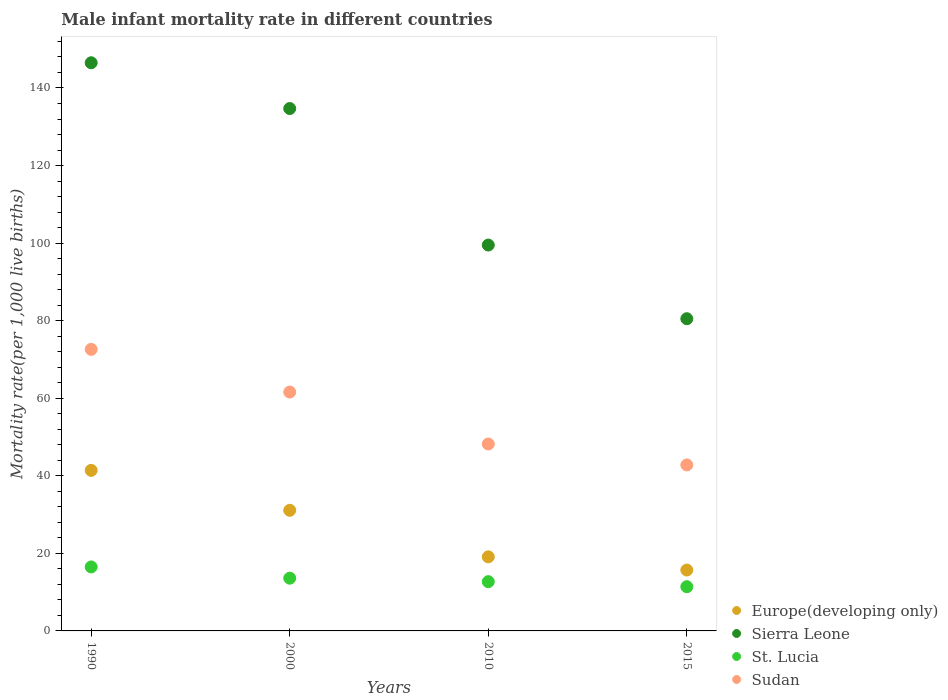What is the male infant mortality rate in Sierra Leone in 1990?
Keep it short and to the point. 146.5. Across all years, what is the minimum male infant mortality rate in Sudan?
Your response must be concise. 42.8. In which year was the male infant mortality rate in Sierra Leone minimum?
Ensure brevity in your answer.  2015. What is the total male infant mortality rate in Sierra Leone in the graph?
Your answer should be compact. 461.2. What is the difference between the male infant mortality rate in Sierra Leone in 1990 and that in 2000?
Your answer should be compact. 11.8. What is the difference between the male infant mortality rate in St. Lucia in 1990 and the male infant mortality rate in Sudan in 2000?
Offer a terse response. -45.1. What is the average male infant mortality rate in St. Lucia per year?
Make the answer very short. 13.55. In the year 1990, what is the difference between the male infant mortality rate in Sudan and male infant mortality rate in St. Lucia?
Provide a succinct answer. 56.1. In how many years, is the male infant mortality rate in St. Lucia greater than 4?
Your answer should be compact. 4. What is the ratio of the male infant mortality rate in Sudan in 1990 to that in 2010?
Make the answer very short. 1.51. Is the male infant mortality rate in St. Lucia in 1990 less than that in 2000?
Ensure brevity in your answer.  No. What is the difference between the highest and the second highest male infant mortality rate in Sudan?
Your answer should be very brief. 11. What is the difference between the highest and the lowest male infant mortality rate in Sudan?
Provide a succinct answer. 29.8. Is the sum of the male infant mortality rate in Sudan in 1990 and 2000 greater than the maximum male infant mortality rate in Sierra Leone across all years?
Make the answer very short. No. Is it the case that in every year, the sum of the male infant mortality rate in St. Lucia and male infant mortality rate in Sierra Leone  is greater than the male infant mortality rate in Sudan?
Your answer should be very brief. Yes. Is the male infant mortality rate in St. Lucia strictly greater than the male infant mortality rate in Sudan over the years?
Your answer should be very brief. No. Is the male infant mortality rate in Europe(developing only) strictly less than the male infant mortality rate in Sierra Leone over the years?
Your response must be concise. Yes. What is the difference between two consecutive major ticks on the Y-axis?
Offer a very short reply. 20. How many legend labels are there?
Provide a short and direct response. 4. What is the title of the graph?
Provide a succinct answer. Male infant mortality rate in different countries. What is the label or title of the Y-axis?
Give a very brief answer. Mortality rate(per 1,0 live births). What is the Mortality rate(per 1,000 live births) in Europe(developing only) in 1990?
Make the answer very short. 41.4. What is the Mortality rate(per 1,000 live births) in Sierra Leone in 1990?
Your answer should be compact. 146.5. What is the Mortality rate(per 1,000 live births) in St. Lucia in 1990?
Your response must be concise. 16.5. What is the Mortality rate(per 1,000 live births) in Sudan in 1990?
Ensure brevity in your answer.  72.6. What is the Mortality rate(per 1,000 live births) of Europe(developing only) in 2000?
Your answer should be very brief. 31.1. What is the Mortality rate(per 1,000 live births) of Sierra Leone in 2000?
Your answer should be compact. 134.7. What is the Mortality rate(per 1,000 live births) in Sudan in 2000?
Make the answer very short. 61.6. What is the Mortality rate(per 1,000 live births) of Sierra Leone in 2010?
Keep it short and to the point. 99.5. What is the Mortality rate(per 1,000 live births) of St. Lucia in 2010?
Provide a succinct answer. 12.7. What is the Mortality rate(per 1,000 live births) of Sudan in 2010?
Ensure brevity in your answer.  48.2. What is the Mortality rate(per 1,000 live births) of Sierra Leone in 2015?
Ensure brevity in your answer.  80.5. What is the Mortality rate(per 1,000 live births) of Sudan in 2015?
Your answer should be very brief. 42.8. Across all years, what is the maximum Mortality rate(per 1,000 live births) in Europe(developing only)?
Keep it short and to the point. 41.4. Across all years, what is the maximum Mortality rate(per 1,000 live births) of Sierra Leone?
Your response must be concise. 146.5. Across all years, what is the maximum Mortality rate(per 1,000 live births) in St. Lucia?
Give a very brief answer. 16.5. Across all years, what is the maximum Mortality rate(per 1,000 live births) of Sudan?
Your answer should be compact. 72.6. Across all years, what is the minimum Mortality rate(per 1,000 live births) of Europe(developing only)?
Keep it short and to the point. 15.7. Across all years, what is the minimum Mortality rate(per 1,000 live births) in Sierra Leone?
Offer a very short reply. 80.5. Across all years, what is the minimum Mortality rate(per 1,000 live births) of Sudan?
Ensure brevity in your answer.  42.8. What is the total Mortality rate(per 1,000 live births) of Europe(developing only) in the graph?
Your response must be concise. 107.3. What is the total Mortality rate(per 1,000 live births) in Sierra Leone in the graph?
Offer a very short reply. 461.2. What is the total Mortality rate(per 1,000 live births) of St. Lucia in the graph?
Offer a very short reply. 54.2. What is the total Mortality rate(per 1,000 live births) of Sudan in the graph?
Ensure brevity in your answer.  225.2. What is the difference between the Mortality rate(per 1,000 live births) of Europe(developing only) in 1990 and that in 2000?
Make the answer very short. 10.3. What is the difference between the Mortality rate(per 1,000 live births) in Sierra Leone in 1990 and that in 2000?
Provide a succinct answer. 11.8. What is the difference between the Mortality rate(per 1,000 live births) in St. Lucia in 1990 and that in 2000?
Keep it short and to the point. 2.9. What is the difference between the Mortality rate(per 1,000 live births) of Europe(developing only) in 1990 and that in 2010?
Provide a succinct answer. 22.3. What is the difference between the Mortality rate(per 1,000 live births) in Sudan in 1990 and that in 2010?
Ensure brevity in your answer.  24.4. What is the difference between the Mortality rate(per 1,000 live births) in Europe(developing only) in 1990 and that in 2015?
Ensure brevity in your answer.  25.7. What is the difference between the Mortality rate(per 1,000 live births) of Sierra Leone in 1990 and that in 2015?
Provide a succinct answer. 66. What is the difference between the Mortality rate(per 1,000 live births) of St. Lucia in 1990 and that in 2015?
Give a very brief answer. 5.1. What is the difference between the Mortality rate(per 1,000 live births) of Sudan in 1990 and that in 2015?
Offer a terse response. 29.8. What is the difference between the Mortality rate(per 1,000 live births) of Sierra Leone in 2000 and that in 2010?
Your answer should be compact. 35.2. What is the difference between the Mortality rate(per 1,000 live births) in Sierra Leone in 2000 and that in 2015?
Make the answer very short. 54.2. What is the difference between the Mortality rate(per 1,000 live births) of Sudan in 2000 and that in 2015?
Offer a terse response. 18.8. What is the difference between the Mortality rate(per 1,000 live births) in Sudan in 2010 and that in 2015?
Your answer should be very brief. 5.4. What is the difference between the Mortality rate(per 1,000 live births) in Europe(developing only) in 1990 and the Mortality rate(per 1,000 live births) in Sierra Leone in 2000?
Your response must be concise. -93.3. What is the difference between the Mortality rate(per 1,000 live births) of Europe(developing only) in 1990 and the Mortality rate(per 1,000 live births) of St. Lucia in 2000?
Ensure brevity in your answer.  27.8. What is the difference between the Mortality rate(per 1,000 live births) of Europe(developing only) in 1990 and the Mortality rate(per 1,000 live births) of Sudan in 2000?
Make the answer very short. -20.2. What is the difference between the Mortality rate(per 1,000 live births) of Sierra Leone in 1990 and the Mortality rate(per 1,000 live births) of St. Lucia in 2000?
Your answer should be compact. 132.9. What is the difference between the Mortality rate(per 1,000 live births) in Sierra Leone in 1990 and the Mortality rate(per 1,000 live births) in Sudan in 2000?
Make the answer very short. 84.9. What is the difference between the Mortality rate(per 1,000 live births) in St. Lucia in 1990 and the Mortality rate(per 1,000 live births) in Sudan in 2000?
Your response must be concise. -45.1. What is the difference between the Mortality rate(per 1,000 live births) of Europe(developing only) in 1990 and the Mortality rate(per 1,000 live births) of Sierra Leone in 2010?
Offer a terse response. -58.1. What is the difference between the Mortality rate(per 1,000 live births) of Europe(developing only) in 1990 and the Mortality rate(per 1,000 live births) of St. Lucia in 2010?
Your answer should be very brief. 28.7. What is the difference between the Mortality rate(per 1,000 live births) of Europe(developing only) in 1990 and the Mortality rate(per 1,000 live births) of Sudan in 2010?
Your response must be concise. -6.8. What is the difference between the Mortality rate(per 1,000 live births) in Sierra Leone in 1990 and the Mortality rate(per 1,000 live births) in St. Lucia in 2010?
Provide a short and direct response. 133.8. What is the difference between the Mortality rate(per 1,000 live births) of Sierra Leone in 1990 and the Mortality rate(per 1,000 live births) of Sudan in 2010?
Your answer should be very brief. 98.3. What is the difference between the Mortality rate(per 1,000 live births) in St. Lucia in 1990 and the Mortality rate(per 1,000 live births) in Sudan in 2010?
Offer a terse response. -31.7. What is the difference between the Mortality rate(per 1,000 live births) in Europe(developing only) in 1990 and the Mortality rate(per 1,000 live births) in Sierra Leone in 2015?
Your answer should be very brief. -39.1. What is the difference between the Mortality rate(per 1,000 live births) in Europe(developing only) in 1990 and the Mortality rate(per 1,000 live births) in St. Lucia in 2015?
Provide a succinct answer. 30. What is the difference between the Mortality rate(per 1,000 live births) in Sierra Leone in 1990 and the Mortality rate(per 1,000 live births) in St. Lucia in 2015?
Provide a succinct answer. 135.1. What is the difference between the Mortality rate(per 1,000 live births) in Sierra Leone in 1990 and the Mortality rate(per 1,000 live births) in Sudan in 2015?
Offer a very short reply. 103.7. What is the difference between the Mortality rate(per 1,000 live births) of St. Lucia in 1990 and the Mortality rate(per 1,000 live births) of Sudan in 2015?
Your answer should be very brief. -26.3. What is the difference between the Mortality rate(per 1,000 live births) in Europe(developing only) in 2000 and the Mortality rate(per 1,000 live births) in Sierra Leone in 2010?
Give a very brief answer. -68.4. What is the difference between the Mortality rate(per 1,000 live births) of Europe(developing only) in 2000 and the Mortality rate(per 1,000 live births) of St. Lucia in 2010?
Keep it short and to the point. 18.4. What is the difference between the Mortality rate(per 1,000 live births) of Europe(developing only) in 2000 and the Mortality rate(per 1,000 live births) of Sudan in 2010?
Your response must be concise. -17.1. What is the difference between the Mortality rate(per 1,000 live births) in Sierra Leone in 2000 and the Mortality rate(per 1,000 live births) in St. Lucia in 2010?
Give a very brief answer. 122. What is the difference between the Mortality rate(per 1,000 live births) of Sierra Leone in 2000 and the Mortality rate(per 1,000 live births) of Sudan in 2010?
Your answer should be compact. 86.5. What is the difference between the Mortality rate(per 1,000 live births) of St. Lucia in 2000 and the Mortality rate(per 1,000 live births) of Sudan in 2010?
Provide a succinct answer. -34.6. What is the difference between the Mortality rate(per 1,000 live births) in Europe(developing only) in 2000 and the Mortality rate(per 1,000 live births) in Sierra Leone in 2015?
Keep it short and to the point. -49.4. What is the difference between the Mortality rate(per 1,000 live births) of Europe(developing only) in 2000 and the Mortality rate(per 1,000 live births) of St. Lucia in 2015?
Your answer should be very brief. 19.7. What is the difference between the Mortality rate(per 1,000 live births) of Europe(developing only) in 2000 and the Mortality rate(per 1,000 live births) of Sudan in 2015?
Provide a short and direct response. -11.7. What is the difference between the Mortality rate(per 1,000 live births) of Sierra Leone in 2000 and the Mortality rate(per 1,000 live births) of St. Lucia in 2015?
Ensure brevity in your answer.  123.3. What is the difference between the Mortality rate(per 1,000 live births) in Sierra Leone in 2000 and the Mortality rate(per 1,000 live births) in Sudan in 2015?
Make the answer very short. 91.9. What is the difference between the Mortality rate(per 1,000 live births) of St. Lucia in 2000 and the Mortality rate(per 1,000 live births) of Sudan in 2015?
Ensure brevity in your answer.  -29.2. What is the difference between the Mortality rate(per 1,000 live births) in Europe(developing only) in 2010 and the Mortality rate(per 1,000 live births) in Sierra Leone in 2015?
Your response must be concise. -61.4. What is the difference between the Mortality rate(per 1,000 live births) in Europe(developing only) in 2010 and the Mortality rate(per 1,000 live births) in St. Lucia in 2015?
Your answer should be compact. 7.7. What is the difference between the Mortality rate(per 1,000 live births) in Europe(developing only) in 2010 and the Mortality rate(per 1,000 live births) in Sudan in 2015?
Your answer should be very brief. -23.7. What is the difference between the Mortality rate(per 1,000 live births) in Sierra Leone in 2010 and the Mortality rate(per 1,000 live births) in St. Lucia in 2015?
Your answer should be compact. 88.1. What is the difference between the Mortality rate(per 1,000 live births) of Sierra Leone in 2010 and the Mortality rate(per 1,000 live births) of Sudan in 2015?
Give a very brief answer. 56.7. What is the difference between the Mortality rate(per 1,000 live births) of St. Lucia in 2010 and the Mortality rate(per 1,000 live births) of Sudan in 2015?
Provide a succinct answer. -30.1. What is the average Mortality rate(per 1,000 live births) in Europe(developing only) per year?
Ensure brevity in your answer.  26.82. What is the average Mortality rate(per 1,000 live births) in Sierra Leone per year?
Give a very brief answer. 115.3. What is the average Mortality rate(per 1,000 live births) in St. Lucia per year?
Offer a terse response. 13.55. What is the average Mortality rate(per 1,000 live births) in Sudan per year?
Keep it short and to the point. 56.3. In the year 1990, what is the difference between the Mortality rate(per 1,000 live births) in Europe(developing only) and Mortality rate(per 1,000 live births) in Sierra Leone?
Your response must be concise. -105.1. In the year 1990, what is the difference between the Mortality rate(per 1,000 live births) of Europe(developing only) and Mortality rate(per 1,000 live births) of St. Lucia?
Provide a succinct answer. 24.9. In the year 1990, what is the difference between the Mortality rate(per 1,000 live births) of Europe(developing only) and Mortality rate(per 1,000 live births) of Sudan?
Provide a short and direct response. -31.2. In the year 1990, what is the difference between the Mortality rate(per 1,000 live births) of Sierra Leone and Mortality rate(per 1,000 live births) of St. Lucia?
Provide a short and direct response. 130. In the year 1990, what is the difference between the Mortality rate(per 1,000 live births) of Sierra Leone and Mortality rate(per 1,000 live births) of Sudan?
Offer a very short reply. 73.9. In the year 1990, what is the difference between the Mortality rate(per 1,000 live births) of St. Lucia and Mortality rate(per 1,000 live births) of Sudan?
Provide a short and direct response. -56.1. In the year 2000, what is the difference between the Mortality rate(per 1,000 live births) of Europe(developing only) and Mortality rate(per 1,000 live births) of Sierra Leone?
Provide a succinct answer. -103.6. In the year 2000, what is the difference between the Mortality rate(per 1,000 live births) in Europe(developing only) and Mortality rate(per 1,000 live births) in St. Lucia?
Your response must be concise. 17.5. In the year 2000, what is the difference between the Mortality rate(per 1,000 live births) of Europe(developing only) and Mortality rate(per 1,000 live births) of Sudan?
Your response must be concise. -30.5. In the year 2000, what is the difference between the Mortality rate(per 1,000 live births) in Sierra Leone and Mortality rate(per 1,000 live births) in St. Lucia?
Provide a short and direct response. 121.1. In the year 2000, what is the difference between the Mortality rate(per 1,000 live births) in Sierra Leone and Mortality rate(per 1,000 live births) in Sudan?
Give a very brief answer. 73.1. In the year 2000, what is the difference between the Mortality rate(per 1,000 live births) of St. Lucia and Mortality rate(per 1,000 live births) of Sudan?
Keep it short and to the point. -48. In the year 2010, what is the difference between the Mortality rate(per 1,000 live births) in Europe(developing only) and Mortality rate(per 1,000 live births) in Sierra Leone?
Offer a very short reply. -80.4. In the year 2010, what is the difference between the Mortality rate(per 1,000 live births) of Europe(developing only) and Mortality rate(per 1,000 live births) of St. Lucia?
Provide a short and direct response. 6.4. In the year 2010, what is the difference between the Mortality rate(per 1,000 live births) in Europe(developing only) and Mortality rate(per 1,000 live births) in Sudan?
Your answer should be compact. -29.1. In the year 2010, what is the difference between the Mortality rate(per 1,000 live births) in Sierra Leone and Mortality rate(per 1,000 live births) in St. Lucia?
Offer a very short reply. 86.8. In the year 2010, what is the difference between the Mortality rate(per 1,000 live births) in Sierra Leone and Mortality rate(per 1,000 live births) in Sudan?
Your answer should be very brief. 51.3. In the year 2010, what is the difference between the Mortality rate(per 1,000 live births) of St. Lucia and Mortality rate(per 1,000 live births) of Sudan?
Offer a terse response. -35.5. In the year 2015, what is the difference between the Mortality rate(per 1,000 live births) in Europe(developing only) and Mortality rate(per 1,000 live births) in Sierra Leone?
Provide a succinct answer. -64.8. In the year 2015, what is the difference between the Mortality rate(per 1,000 live births) of Europe(developing only) and Mortality rate(per 1,000 live births) of St. Lucia?
Provide a short and direct response. 4.3. In the year 2015, what is the difference between the Mortality rate(per 1,000 live births) of Europe(developing only) and Mortality rate(per 1,000 live births) of Sudan?
Keep it short and to the point. -27.1. In the year 2015, what is the difference between the Mortality rate(per 1,000 live births) in Sierra Leone and Mortality rate(per 1,000 live births) in St. Lucia?
Give a very brief answer. 69.1. In the year 2015, what is the difference between the Mortality rate(per 1,000 live births) in Sierra Leone and Mortality rate(per 1,000 live births) in Sudan?
Offer a terse response. 37.7. In the year 2015, what is the difference between the Mortality rate(per 1,000 live births) of St. Lucia and Mortality rate(per 1,000 live births) of Sudan?
Provide a short and direct response. -31.4. What is the ratio of the Mortality rate(per 1,000 live births) in Europe(developing only) in 1990 to that in 2000?
Give a very brief answer. 1.33. What is the ratio of the Mortality rate(per 1,000 live births) of Sierra Leone in 1990 to that in 2000?
Give a very brief answer. 1.09. What is the ratio of the Mortality rate(per 1,000 live births) in St. Lucia in 1990 to that in 2000?
Offer a very short reply. 1.21. What is the ratio of the Mortality rate(per 1,000 live births) of Sudan in 1990 to that in 2000?
Offer a very short reply. 1.18. What is the ratio of the Mortality rate(per 1,000 live births) of Europe(developing only) in 1990 to that in 2010?
Offer a terse response. 2.17. What is the ratio of the Mortality rate(per 1,000 live births) in Sierra Leone in 1990 to that in 2010?
Give a very brief answer. 1.47. What is the ratio of the Mortality rate(per 1,000 live births) in St. Lucia in 1990 to that in 2010?
Your answer should be very brief. 1.3. What is the ratio of the Mortality rate(per 1,000 live births) of Sudan in 1990 to that in 2010?
Offer a terse response. 1.51. What is the ratio of the Mortality rate(per 1,000 live births) of Europe(developing only) in 1990 to that in 2015?
Your answer should be compact. 2.64. What is the ratio of the Mortality rate(per 1,000 live births) of Sierra Leone in 1990 to that in 2015?
Your answer should be very brief. 1.82. What is the ratio of the Mortality rate(per 1,000 live births) in St. Lucia in 1990 to that in 2015?
Offer a very short reply. 1.45. What is the ratio of the Mortality rate(per 1,000 live births) of Sudan in 1990 to that in 2015?
Offer a terse response. 1.7. What is the ratio of the Mortality rate(per 1,000 live births) of Europe(developing only) in 2000 to that in 2010?
Offer a very short reply. 1.63. What is the ratio of the Mortality rate(per 1,000 live births) of Sierra Leone in 2000 to that in 2010?
Give a very brief answer. 1.35. What is the ratio of the Mortality rate(per 1,000 live births) of St. Lucia in 2000 to that in 2010?
Provide a succinct answer. 1.07. What is the ratio of the Mortality rate(per 1,000 live births) of Sudan in 2000 to that in 2010?
Offer a terse response. 1.28. What is the ratio of the Mortality rate(per 1,000 live births) of Europe(developing only) in 2000 to that in 2015?
Your answer should be compact. 1.98. What is the ratio of the Mortality rate(per 1,000 live births) of Sierra Leone in 2000 to that in 2015?
Offer a very short reply. 1.67. What is the ratio of the Mortality rate(per 1,000 live births) of St. Lucia in 2000 to that in 2015?
Provide a succinct answer. 1.19. What is the ratio of the Mortality rate(per 1,000 live births) in Sudan in 2000 to that in 2015?
Your answer should be compact. 1.44. What is the ratio of the Mortality rate(per 1,000 live births) of Europe(developing only) in 2010 to that in 2015?
Ensure brevity in your answer.  1.22. What is the ratio of the Mortality rate(per 1,000 live births) in Sierra Leone in 2010 to that in 2015?
Your response must be concise. 1.24. What is the ratio of the Mortality rate(per 1,000 live births) of St. Lucia in 2010 to that in 2015?
Your answer should be compact. 1.11. What is the ratio of the Mortality rate(per 1,000 live births) in Sudan in 2010 to that in 2015?
Offer a very short reply. 1.13. What is the difference between the highest and the second highest Mortality rate(per 1,000 live births) in Europe(developing only)?
Your answer should be very brief. 10.3. What is the difference between the highest and the second highest Mortality rate(per 1,000 live births) in Sierra Leone?
Give a very brief answer. 11.8. What is the difference between the highest and the second highest Mortality rate(per 1,000 live births) in St. Lucia?
Make the answer very short. 2.9. What is the difference between the highest and the second highest Mortality rate(per 1,000 live births) of Sudan?
Ensure brevity in your answer.  11. What is the difference between the highest and the lowest Mortality rate(per 1,000 live births) in Europe(developing only)?
Provide a short and direct response. 25.7. What is the difference between the highest and the lowest Mortality rate(per 1,000 live births) in Sierra Leone?
Your answer should be very brief. 66. What is the difference between the highest and the lowest Mortality rate(per 1,000 live births) of St. Lucia?
Offer a terse response. 5.1. What is the difference between the highest and the lowest Mortality rate(per 1,000 live births) of Sudan?
Your answer should be compact. 29.8. 